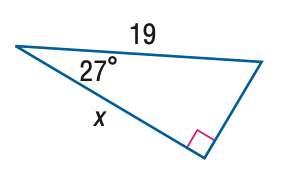Answer the mathemtical geometry problem and directly provide the correct option letter.
Question: Find x. Round to the nearest hundredth.
Choices: A: 8.63 B: 9.68 C: 16.93 D: 41.85 C 